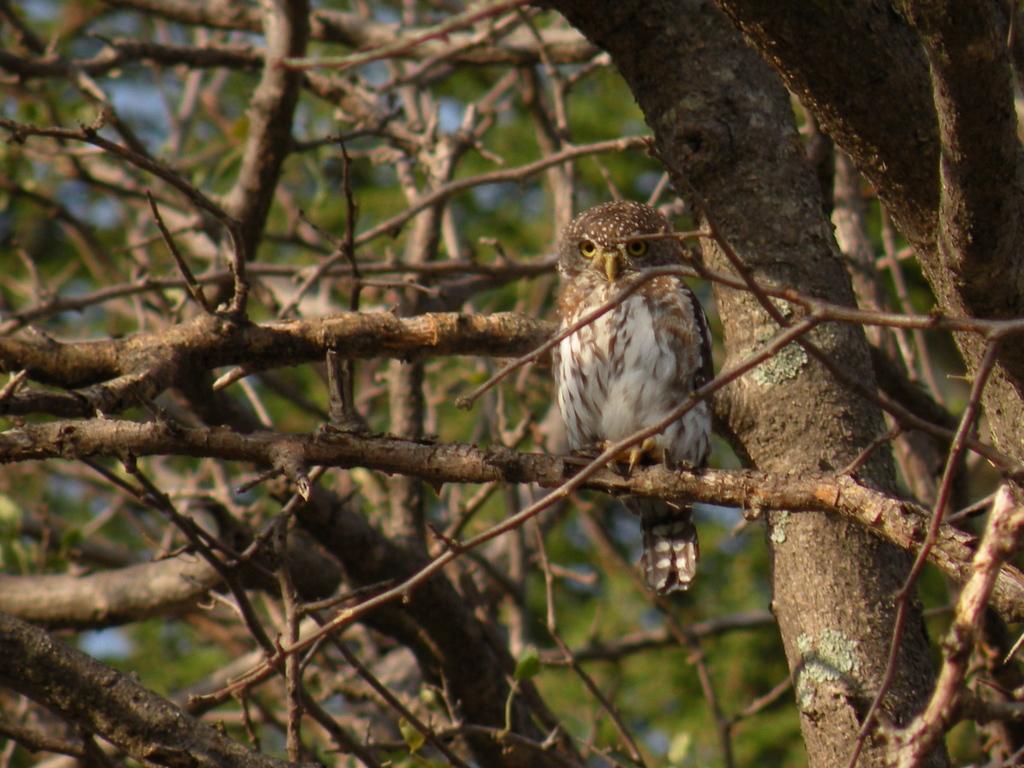Please provide a concise description of this image. In the image there is an owl standing on the branch of the tree. There are many branches of the tree. There is a green color background. 